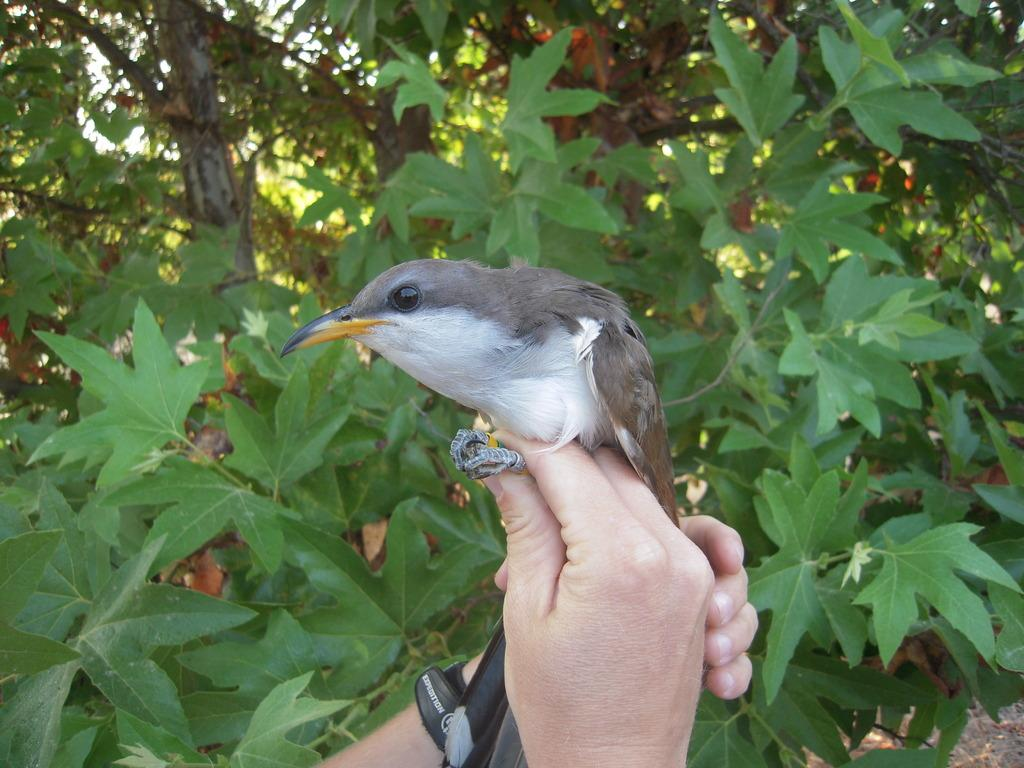What can be seen in the image involving a person's hands? There are hands of a person in the image, and a bird is sitting on the hand. What is the bird doing in the image? The bird is sitting on the hand of the person. What can be seen in the background of the image? There are green color leaves in the background of the image. How many books are stacked on the cabbage in the image? There are no books or cabbage present in the image. What type of activity is the person engaging in with the bird in the image? The image only shows a bird sitting on the person's hand, so it is not possible to determine any specific activity. 